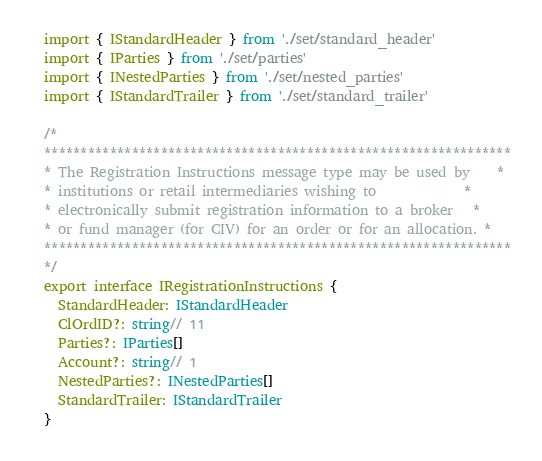<code> <loc_0><loc_0><loc_500><loc_500><_TypeScript_>import { IStandardHeader } from './set/standard_header'
import { IParties } from './set/parties'
import { INestedParties } from './set/nested_parties'
import { IStandardTrailer } from './set/standard_trailer'

/*
****************************************************************
* The Registration Instructions message type may be used by    *
* institutions or retail intermediaries wishing to             *
* electronically submit registration information to a broker   *
* or fund manager (for CIV) for an order or for an allocation. *
****************************************************************
*/
export interface IRegistrationInstructions {
  StandardHeader: IStandardHeader
  ClOrdID?: string// 11
  Parties?: IParties[]
  Account?: string// 1
  NestedParties?: INestedParties[]
  StandardTrailer: IStandardTrailer
}
</code> 